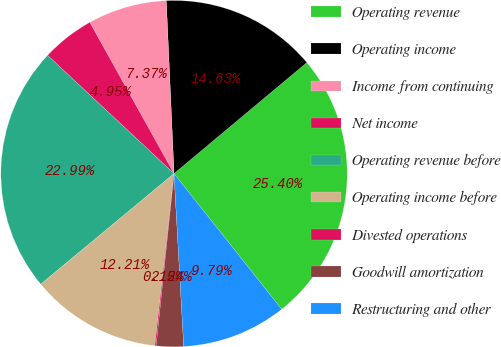Convert chart. <chart><loc_0><loc_0><loc_500><loc_500><pie_chart><fcel>Operating revenue<fcel>Operating income<fcel>Income from continuing<fcel>Net income<fcel>Operating revenue before<fcel>Operating income before<fcel>Divested operations<fcel>Goodwill amortization<fcel>Restructuring and other<nl><fcel>25.4%<fcel>14.63%<fcel>7.37%<fcel>4.95%<fcel>22.99%<fcel>12.21%<fcel>0.12%<fcel>2.54%<fcel>9.79%<nl></chart> 